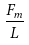Convert formula to latex. <formula><loc_0><loc_0><loc_500><loc_500>\frac { F _ { m } } { L }</formula> 